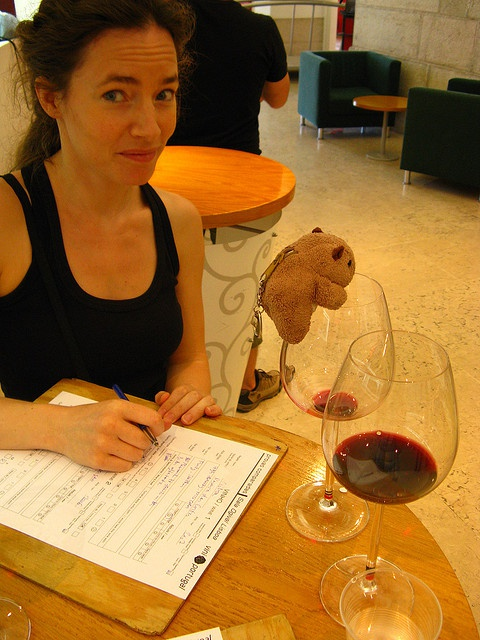Describe the objects in this image and their specific colors. I can see dining table in maroon, khaki, orange, and red tones, people in maroon, black, brown, and orange tones, wine glass in maroon, orange, and red tones, people in maroon, black, and brown tones, and wine glass in maroon, orange, and red tones in this image. 